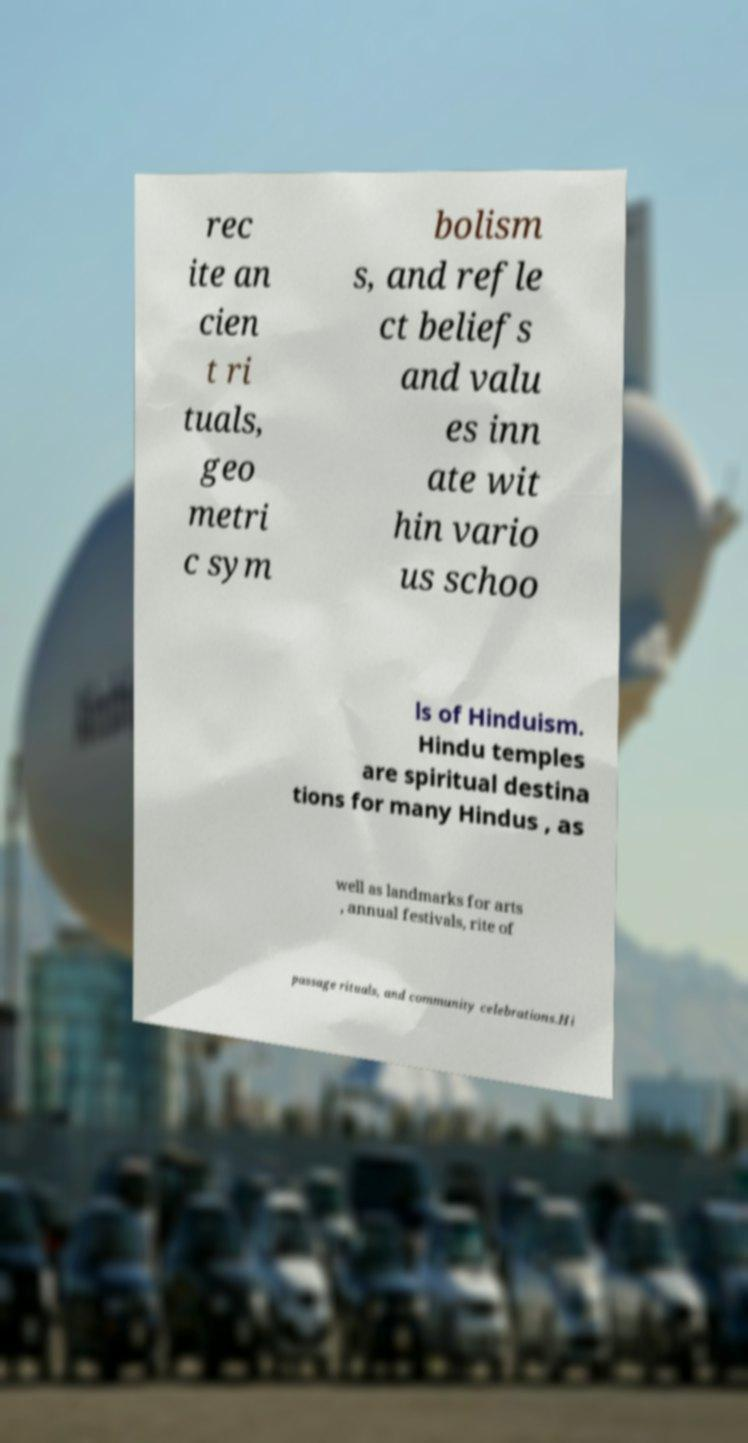Please identify and transcribe the text found in this image. rec ite an cien t ri tuals, geo metri c sym bolism s, and refle ct beliefs and valu es inn ate wit hin vario us schoo ls of Hinduism. Hindu temples are spiritual destina tions for many Hindus , as well as landmarks for arts , annual festivals, rite of passage rituals, and community celebrations.Hi 